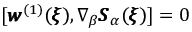<formula> <loc_0><loc_0><loc_500><loc_500>[ { \pm b w } ^ { ( 1 ) } ( { \pm b \xi } ) , \nabla _ { \beta } { \pm b S } _ { \alpha } ( { \pm b \xi } ) ] = 0</formula> 